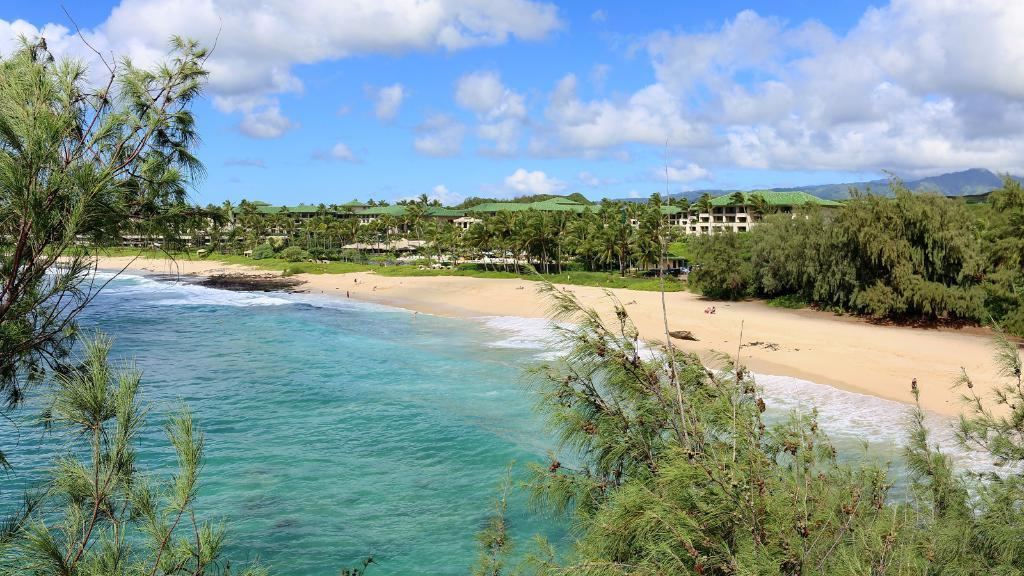What type of location is depicted in the image? There is a beach in the image. What natural element is visible at the beach? There is water visible in the image. What type of vegetation can be seen in the image? There are trees in the image. What man-made structures are present in the image? There are buildings in the image. What can be seen in the sky in the image? There are clouds in the image, and the sky is visible. What type of prose is being recited by the minister in the image? There is no minister or prose present in the image; it features a beach with water, trees, buildings, clouds, and the sky. 